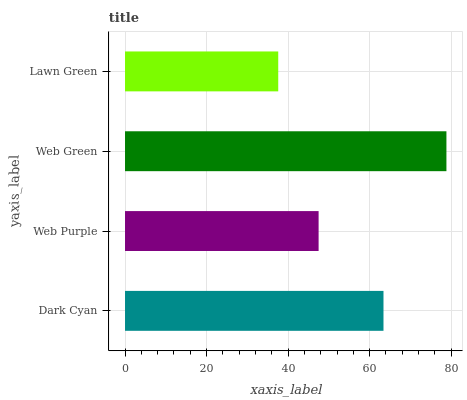Is Lawn Green the minimum?
Answer yes or no. Yes. Is Web Green the maximum?
Answer yes or no. Yes. Is Web Purple the minimum?
Answer yes or no. No. Is Web Purple the maximum?
Answer yes or no. No. Is Dark Cyan greater than Web Purple?
Answer yes or no. Yes. Is Web Purple less than Dark Cyan?
Answer yes or no. Yes. Is Web Purple greater than Dark Cyan?
Answer yes or no. No. Is Dark Cyan less than Web Purple?
Answer yes or no. No. Is Dark Cyan the high median?
Answer yes or no. Yes. Is Web Purple the low median?
Answer yes or no. Yes. Is Web Green the high median?
Answer yes or no. No. Is Lawn Green the low median?
Answer yes or no. No. 